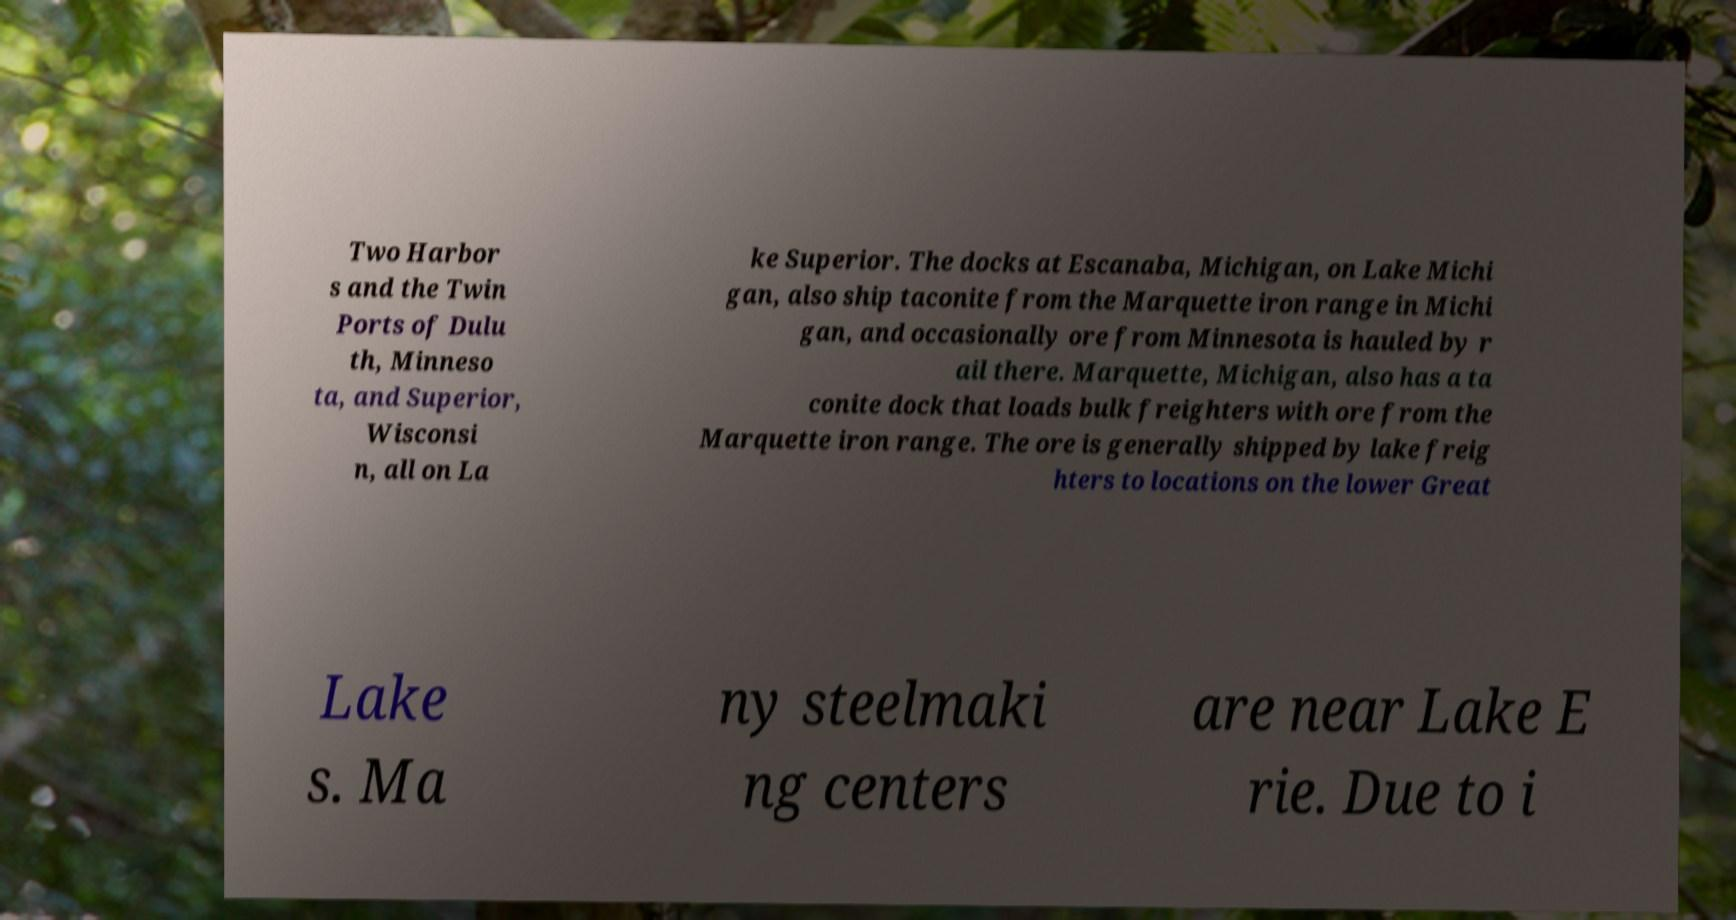Please identify and transcribe the text found in this image. Two Harbor s and the Twin Ports of Dulu th, Minneso ta, and Superior, Wisconsi n, all on La ke Superior. The docks at Escanaba, Michigan, on Lake Michi gan, also ship taconite from the Marquette iron range in Michi gan, and occasionally ore from Minnesota is hauled by r ail there. Marquette, Michigan, also has a ta conite dock that loads bulk freighters with ore from the Marquette iron range. The ore is generally shipped by lake freig hters to locations on the lower Great Lake s. Ma ny steelmaki ng centers are near Lake E rie. Due to i 